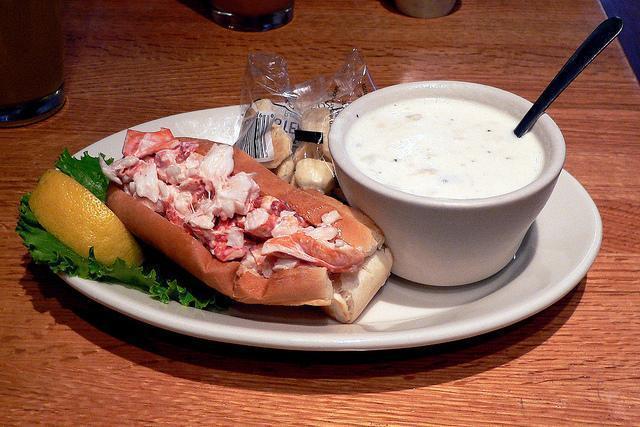What kind of citrus fruit is on top of the leaf on the right side of the white plate?
Indicate the correct response by choosing from the four available options to answer the question.
Options: Lemon, grapefruit, orange, lime. Lemon. 